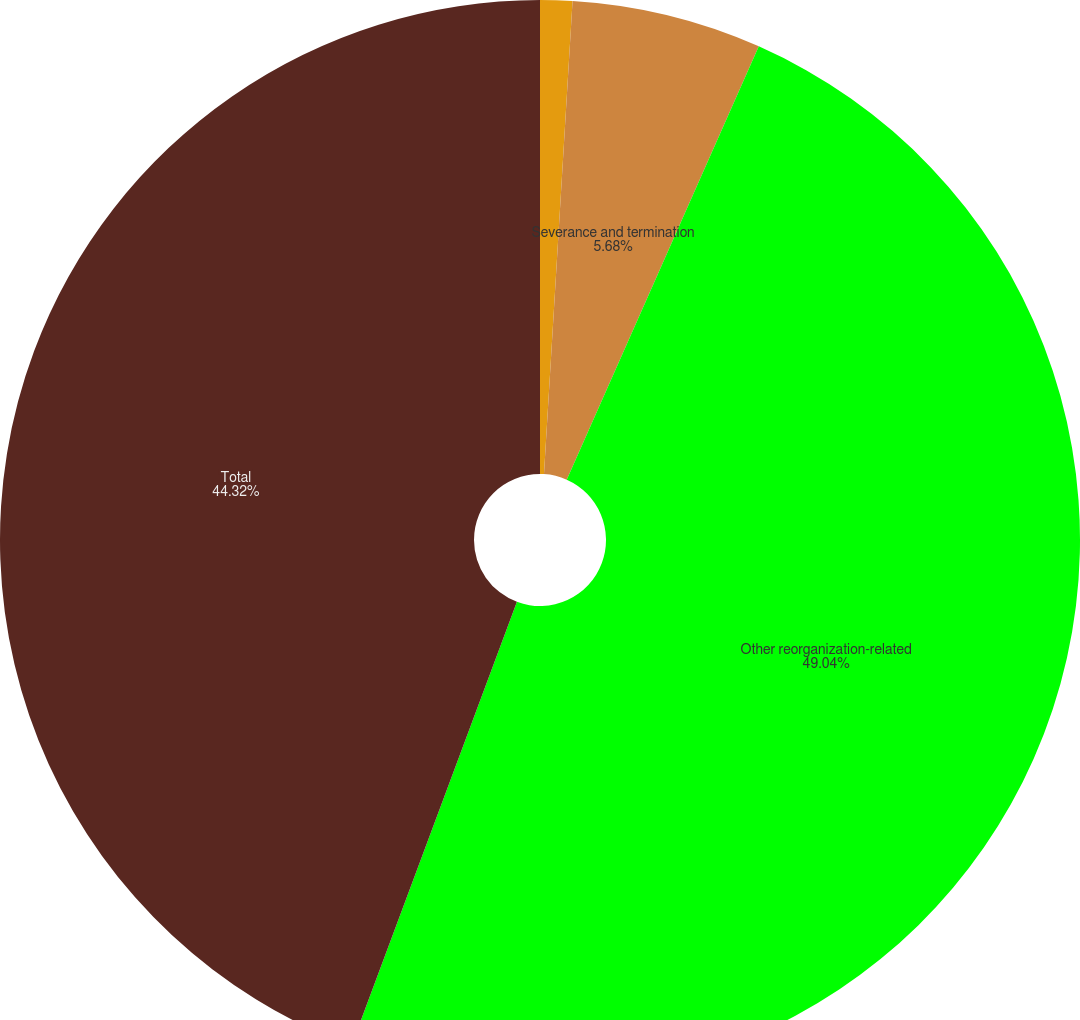<chart> <loc_0><loc_0><loc_500><loc_500><pie_chart><fcel>Lease termination and other<fcel>Severance and termination<fcel>Other reorganization-related<fcel>Total<nl><fcel>0.96%<fcel>5.68%<fcel>49.04%<fcel>44.32%<nl></chart> 